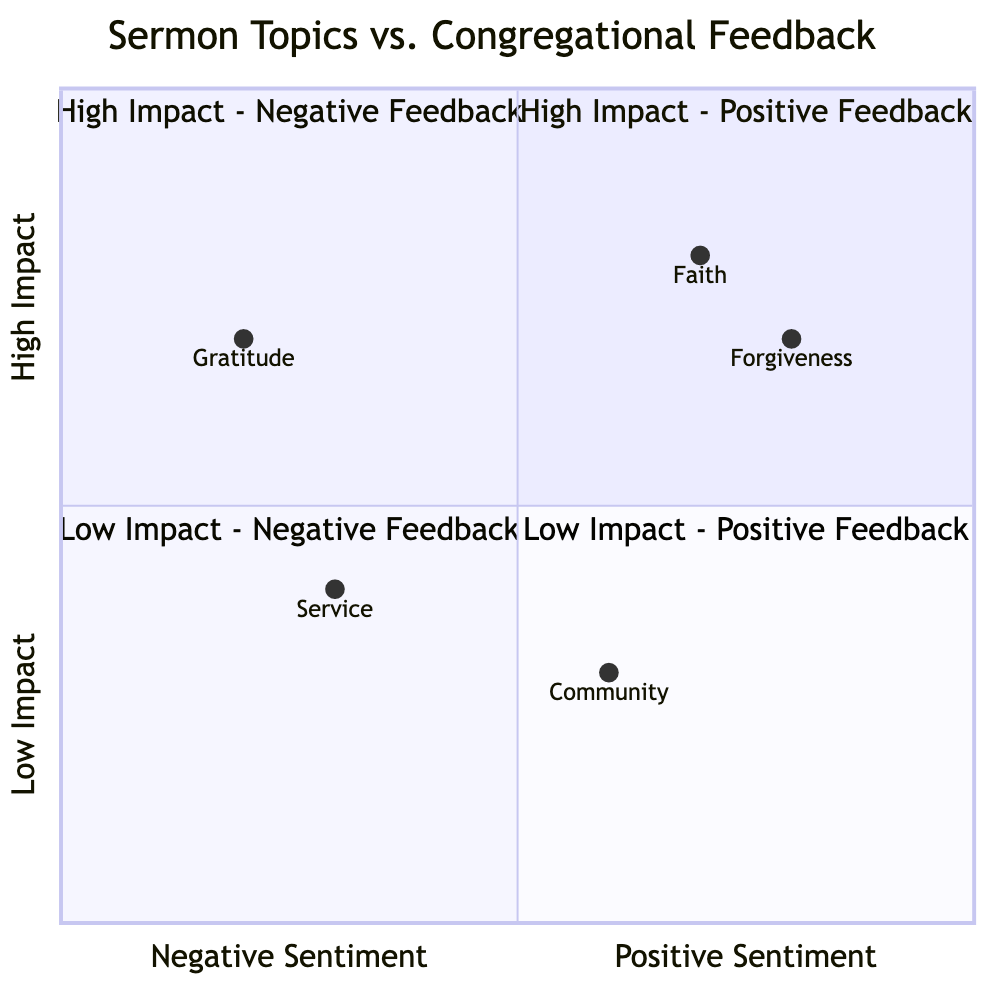What are the two sermon topics in the High Impact - Positive Feedback quadrant? The High Impact - Positive Feedback quadrant contains the topics of Faith and Forgiveness, which are directly listed in the quadrant details of the chart.
Answer: Faith, Forgiveness Which sermon topic is positioned in the Low Impact - Positive Feedback quadrant? The topic in the Low Impact - Positive Feedback quadrant is Community, as indicated in the quadrant's description and topic list.
Answer: Community How many sermon topics received negative feedback? There are two sermon topics that received negative feedback: Gratitude and Service, which are specified in the congregational feedback data.
Answer: Two Which sermon topic has the highest positive sentiment on the chart? The highest positive sentiment is associated with the topic of Forgiveness, as it is placed highest on the positive sentiment axis among the topics.
Answer: Forgiveness What is the feedback sentiment associated with the sermon topic Service? The feedback sentiment for the topic Service is negative, as listed in the congregational feedback and confirmed by its position in the Low Impact - Negative Feedback quadrant.
Answer: Negative Which quadrant contains only one sermon topic and what is that topic? The quadrant with only one sermon topic is the Low Impact - Negative Feedback quadrant, and the topic is Service, as it is the only one mentioned in that specific quadrant description.
Answer: Service How does the sentiment for the topic Gratitude compare to that of Community? Gratitude has a negative sentiment while Community has a neutral sentiment, which shows that Gratitude is received less positively than Community based on their respective placements.
Answer: Gratitude is negative, Community is neutral What is the placement of the sermon topic Faith on the quadrant chart? Faith is located in the High Impact - Positive Feedback quadrant, indicating it has both high impact and positive feedback based on the chart data.
Answer: High Impact - Positive Feedback 